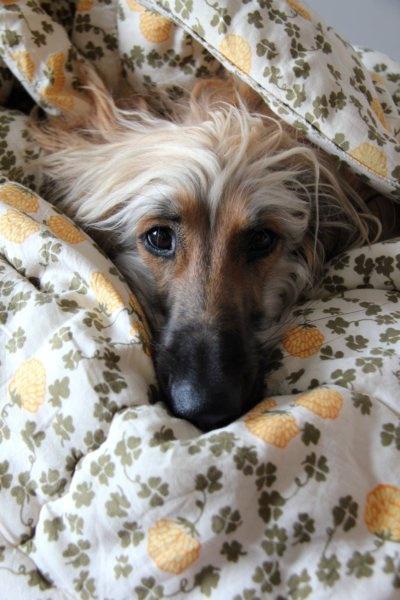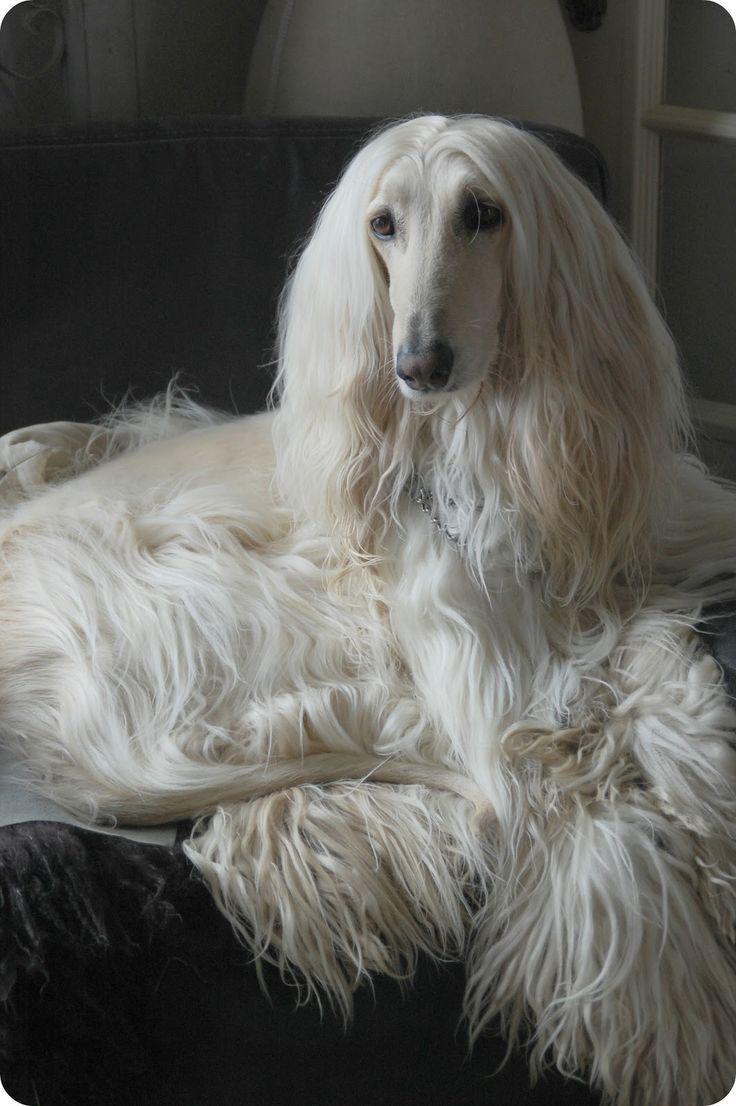The first image is the image on the left, the second image is the image on the right. Analyze the images presented: Is the assertion "One dog is standing and one dog is laying down." valid? Answer yes or no. No. The first image is the image on the left, the second image is the image on the right. Analyze the images presented: Is the assertion "One image shows a single afghan hound lying on a soft material with a print pattern in the scene, and the other image shows one forward-facing afghan with parted hair." valid? Answer yes or no. Yes. 